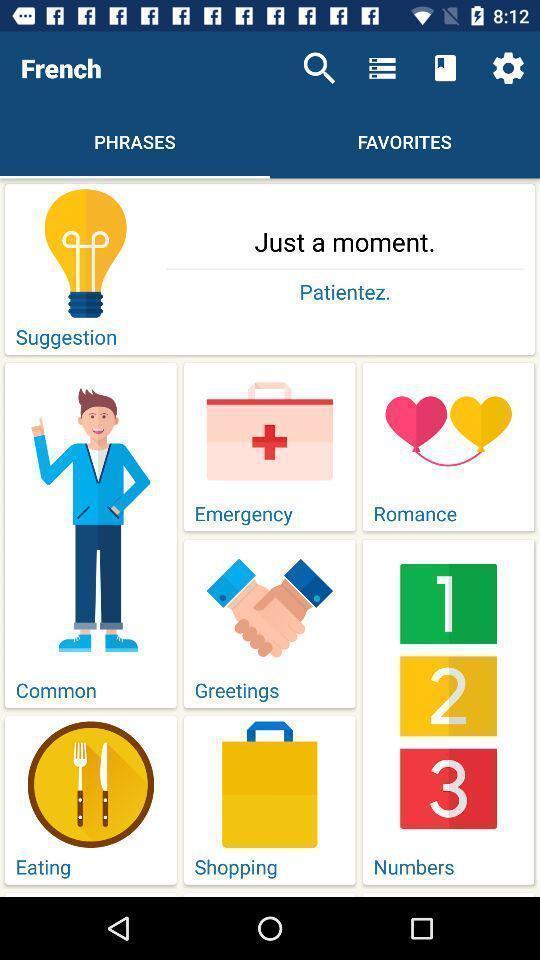Describe the content in this image. Phrases page of a french learning app. 